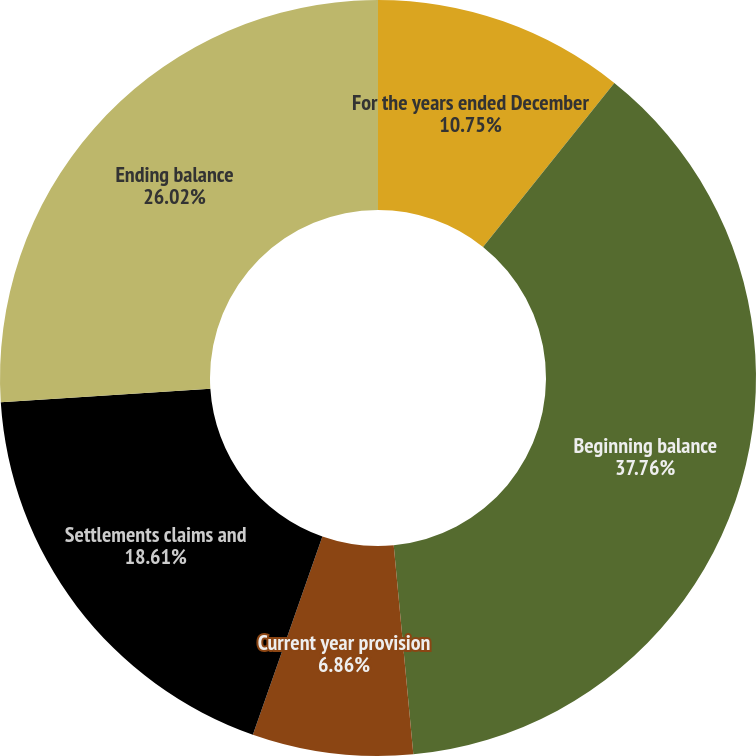Convert chart. <chart><loc_0><loc_0><loc_500><loc_500><pie_chart><fcel>For the years ended December<fcel>Beginning balance<fcel>Current year provision<fcel>Settlements claims and<fcel>Ending balance<nl><fcel>10.75%<fcel>37.76%<fcel>6.86%<fcel>18.61%<fcel>26.02%<nl></chart> 